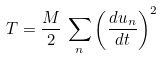Convert formula to latex. <formula><loc_0><loc_0><loc_500><loc_500>T = \frac { M } { 2 } \, \sum _ { n } \left ( \frac { d u _ { n } } { d t } \right ) ^ { 2 }</formula> 